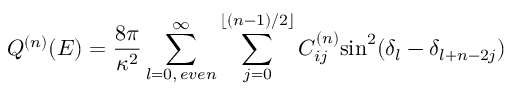Convert formula to latex. <formula><loc_0><loc_0><loc_500><loc_500>Q ^ { ( n ) } ( E ) = \frac { 8 \pi } { \kappa ^ { 2 } } \sum _ { l = 0 , \, e v e n } ^ { \infty } \sum _ { j = 0 } ^ { \lfloor ( n - 1 ) / 2 \rfloor } C _ { i j } ^ { ( n ) } \sin ^ { 2 } ( \delta _ { l } - \delta _ { l + n - 2 j } )</formula> 